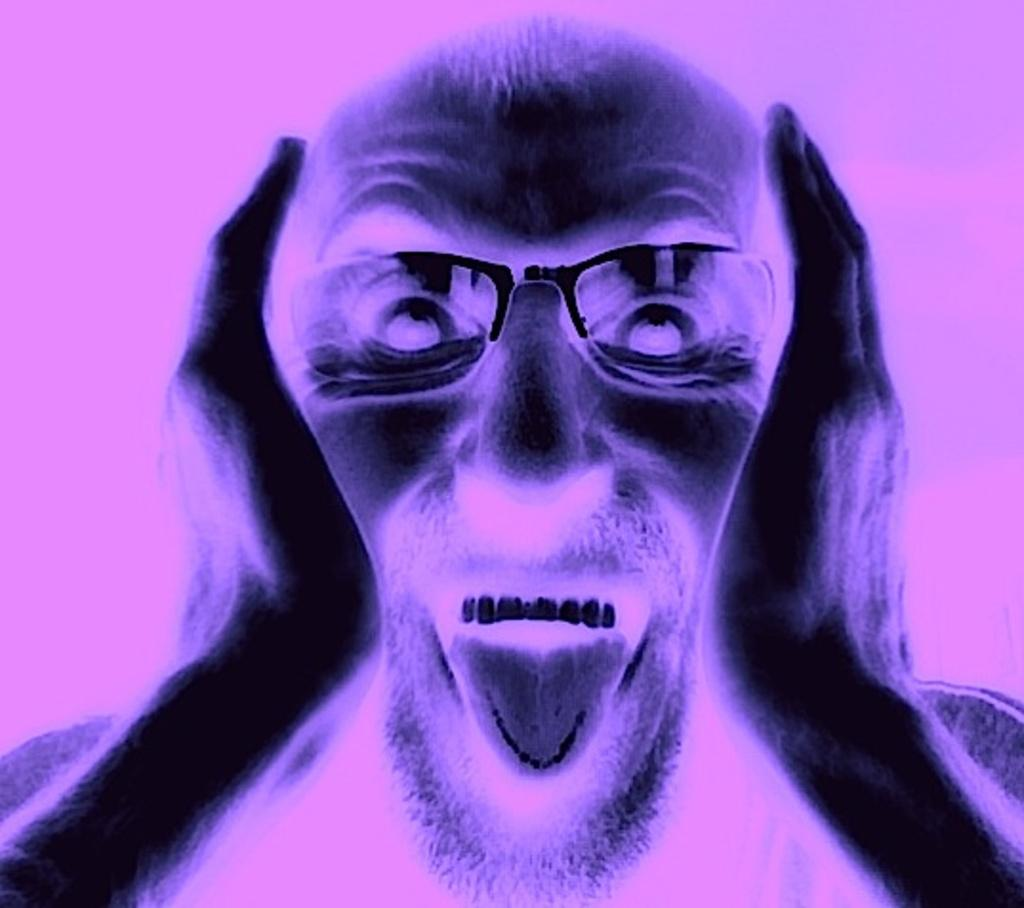What type of image is being described? The image is animated. Can you describe the person in the image? There is a person in the image, and they are wearing spectacles. What is the person doing with his hands in the image? The person has both hands on his cheeks. How does the person appear to be feeling in the image? The person appears to be excited. What is the color of the background in the image? The background color is pink. What is the name of the person's daughter in the image? There is no mention of a daughter in the image, as the focus is on the person and their actions. What type of throat condition does the person have in the image? There is no indication of any throat condition in the image; the person's focus is on their excitement and hand placement. 